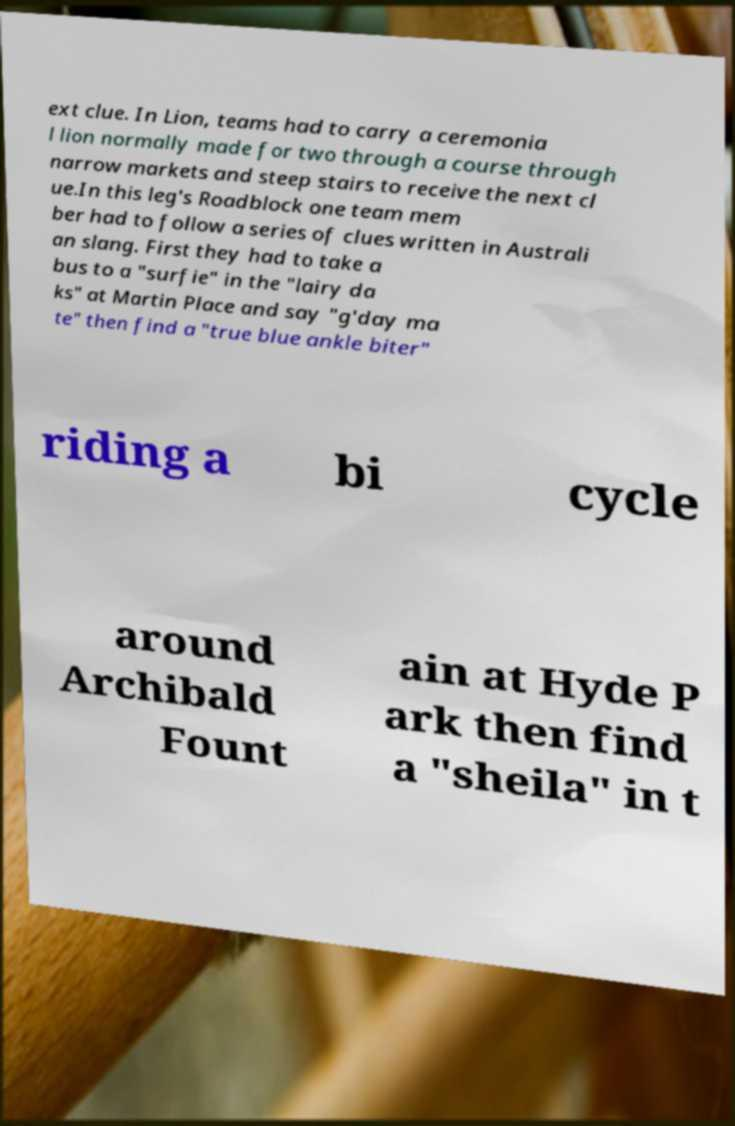There's text embedded in this image that I need extracted. Can you transcribe it verbatim? ext clue. In Lion, teams had to carry a ceremonia l lion normally made for two through a course through narrow markets and steep stairs to receive the next cl ue.In this leg's Roadblock one team mem ber had to follow a series of clues written in Australi an slang. First they had to take a bus to a "surfie" in the "lairy da ks" at Martin Place and say "g'day ma te" then find a "true blue ankle biter" riding a bi cycle around Archibald Fount ain at Hyde P ark then find a "sheila" in t 